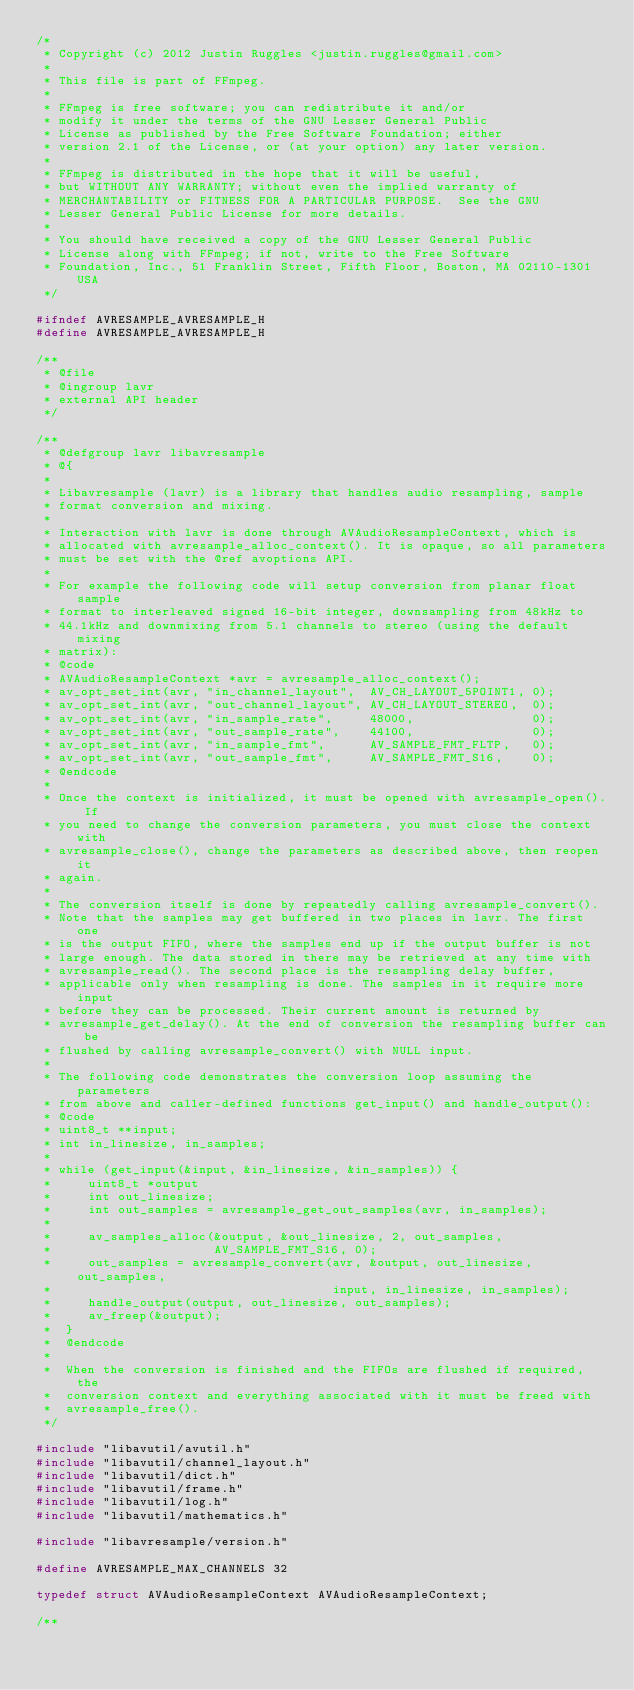<code> <loc_0><loc_0><loc_500><loc_500><_C_>/*
 * Copyright (c) 2012 Justin Ruggles <justin.ruggles@gmail.com>
 *
 * This file is part of FFmpeg.
 *
 * FFmpeg is free software; you can redistribute it and/or
 * modify it under the terms of the GNU Lesser General Public
 * License as published by the Free Software Foundation; either
 * version 2.1 of the License, or (at your option) any later version.
 *
 * FFmpeg is distributed in the hope that it will be useful,
 * but WITHOUT ANY WARRANTY; without even the implied warranty of
 * MERCHANTABILITY or FITNESS FOR A PARTICULAR PURPOSE.  See the GNU
 * Lesser General Public License for more details.
 *
 * You should have received a copy of the GNU Lesser General Public
 * License along with FFmpeg; if not, write to the Free Software
 * Foundation, Inc., 51 Franklin Street, Fifth Floor, Boston, MA 02110-1301 USA
 */

#ifndef AVRESAMPLE_AVRESAMPLE_H
#define AVRESAMPLE_AVRESAMPLE_H

/**
 * @file
 * @ingroup lavr
 * external API header
 */

/**
 * @defgroup lavr libavresample
 * @{
 *
 * Libavresample (lavr) is a library that handles audio resampling, sample
 * format conversion and mixing.
 *
 * Interaction with lavr is done through AVAudioResampleContext, which is
 * allocated with avresample_alloc_context(). It is opaque, so all parameters
 * must be set with the @ref avoptions API.
 *
 * For example the following code will setup conversion from planar float sample
 * format to interleaved signed 16-bit integer, downsampling from 48kHz to
 * 44.1kHz and downmixing from 5.1 channels to stereo (using the default mixing
 * matrix):
 * @code
 * AVAudioResampleContext *avr = avresample_alloc_context();
 * av_opt_set_int(avr, "in_channel_layout",  AV_CH_LAYOUT_5POINT1, 0);
 * av_opt_set_int(avr, "out_channel_layout", AV_CH_LAYOUT_STEREO,  0);
 * av_opt_set_int(avr, "in_sample_rate",     48000,                0);
 * av_opt_set_int(avr, "out_sample_rate",    44100,                0);
 * av_opt_set_int(avr, "in_sample_fmt",      AV_SAMPLE_FMT_FLTP,   0);
 * av_opt_set_int(avr, "out_sample_fmt",     AV_SAMPLE_FMT_S16,    0);
 * @endcode
 *
 * Once the context is initialized, it must be opened with avresample_open(). If
 * you need to change the conversion parameters, you must close the context with
 * avresample_close(), change the parameters as described above, then reopen it
 * again.
 *
 * The conversion itself is done by repeatedly calling avresample_convert().
 * Note that the samples may get buffered in two places in lavr. The first one
 * is the output FIFO, where the samples end up if the output buffer is not
 * large enough. The data stored in there may be retrieved at any time with
 * avresample_read(). The second place is the resampling delay buffer,
 * applicable only when resampling is done. The samples in it require more input
 * before they can be processed. Their current amount is returned by
 * avresample_get_delay(). At the end of conversion the resampling buffer can be
 * flushed by calling avresample_convert() with NULL input.
 *
 * The following code demonstrates the conversion loop assuming the parameters
 * from above and caller-defined functions get_input() and handle_output():
 * @code
 * uint8_t **input;
 * int in_linesize, in_samples;
 *
 * while (get_input(&input, &in_linesize, &in_samples)) {
 *     uint8_t *output
 *     int out_linesize;
 *     int out_samples = avresample_get_out_samples(avr, in_samples);
 *
 *     av_samples_alloc(&output, &out_linesize, 2, out_samples,
 *                      AV_SAMPLE_FMT_S16, 0);
 *     out_samples = avresample_convert(avr, &output, out_linesize, out_samples,
 *                                      input, in_linesize, in_samples);
 *     handle_output(output, out_linesize, out_samples);
 *     av_freep(&output);
 *  }
 *  @endcode
 *
 *  When the conversion is finished and the FIFOs are flushed if required, the
 *  conversion context and everything associated with it must be freed with
 *  avresample_free().
 */

#include "libavutil/avutil.h"
#include "libavutil/channel_layout.h"
#include "libavutil/dict.h"
#include "libavutil/frame.h"
#include "libavutil/log.h"
#include "libavutil/mathematics.h"

#include "libavresample/version.h"

#define AVRESAMPLE_MAX_CHANNELS 32

typedef struct AVAudioResampleContext AVAudioResampleContext;

/**</code> 